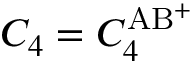Convert formula to latex. <formula><loc_0><loc_0><loc_500><loc_500>C _ { 4 } = C _ { 4 } ^ { A B ^ { + } }</formula> 